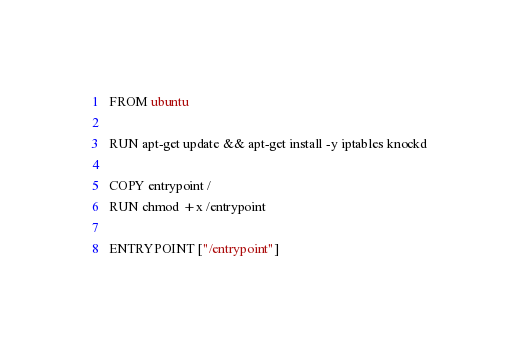<code> <loc_0><loc_0><loc_500><loc_500><_Dockerfile_>FROM ubuntu

RUN apt-get update && apt-get install -y iptables knockd

COPY entrypoint /
RUN chmod +x /entrypoint

ENTRYPOINT ["/entrypoint"]
</code> 